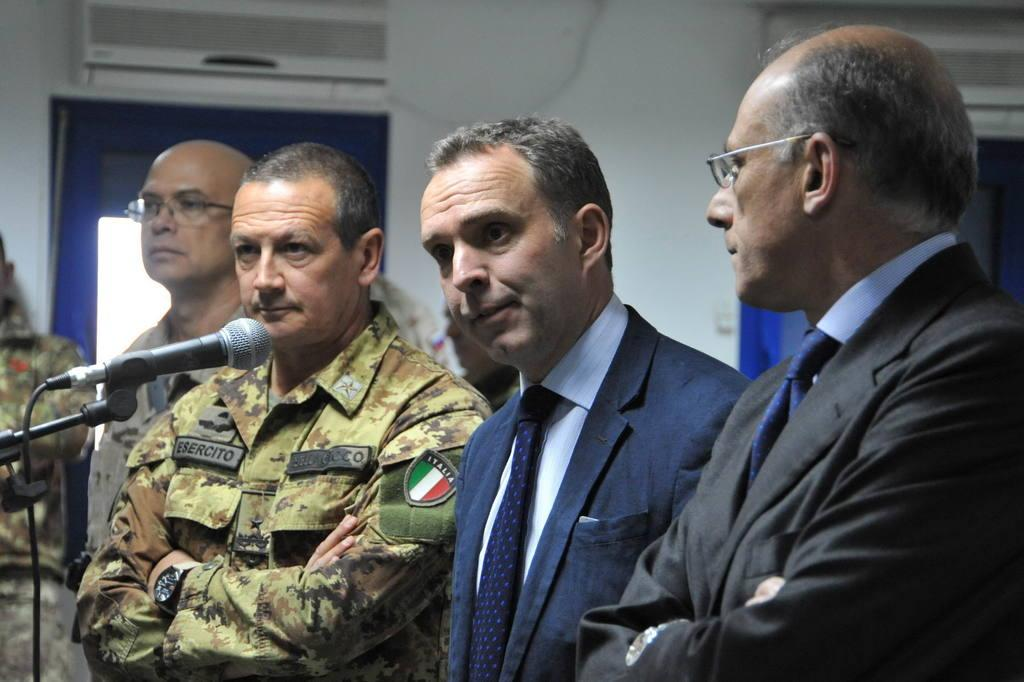Who or what is present in the image? There are people in the image. What object is visible that is typically used for amplifying sound? There is a microphone in the image. What device can be seen in the image that is used for cooling a room? There is an air conditioner in the image. What type of structure is present in the image that separates spaces? There is a wall in the image. What feature is present in the image that allows for passage between spaces? There is a door in the image. What type of impulse can be seen affecting the people in the image? There is no impulse affecting the people in the image; they are simply present. How do the people in the image say good-bye to each other? There is no indication of the people saying good-bye to each other in the image. 